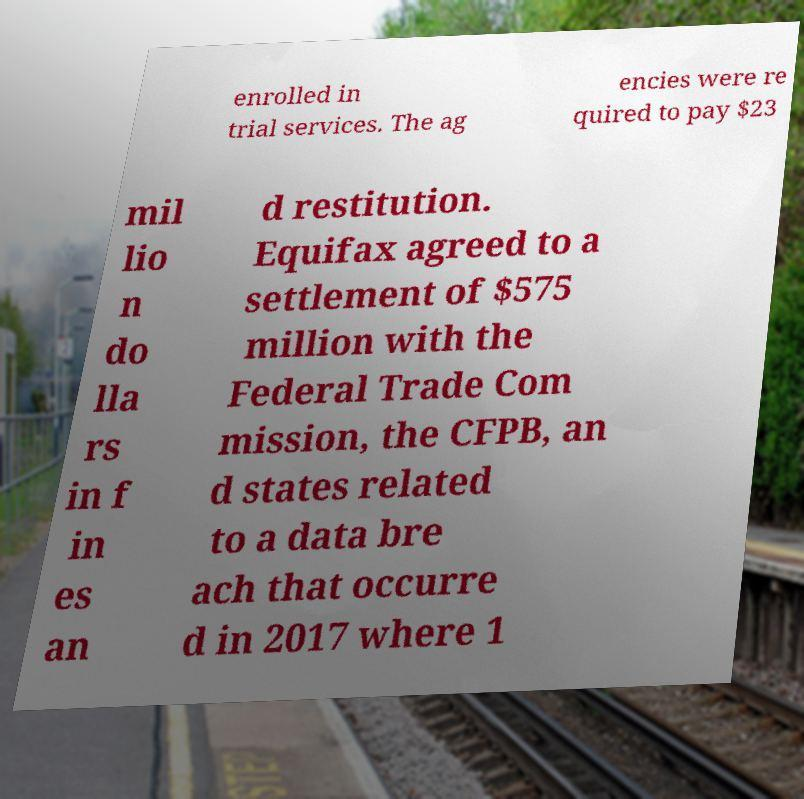What messages or text are displayed in this image? I need them in a readable, typed format. enrolled in trial services. The ag encies were re quired to pay $23 mil lio n do lla rs in f in es an d restitution. Equifax agreed to a settlement of $575 million with the Federal Trade Com mission, the CFPB, an d states related to a data bre ach that occurre d in 2017 where 1 